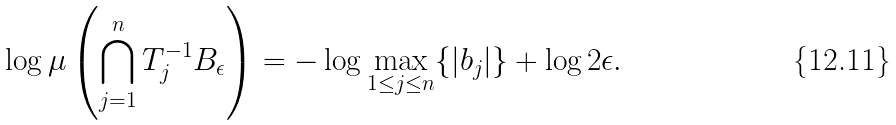Convert formula to latex. <formula><loc_0><loc_0><loc_500><loc_500>\log \mu \left ( \bigcap _ { j = 1 } ^ { n } T _ { j } ^ { - 1 } B _ { \epsilon } \right ) = - \log \max _ { 1 \leq j \leq n } \{ | b _ { j } | \} + \log 2 \epsilon .</formula> 